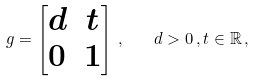<formula> <loc_0><loc_0><loc_500><loc_500>g = \begin{bmatrix} d & t \\ 0 & 1 \end{bmatrix} \, , \quad d > 0 \, , t \in \mathbb { R } \, ,</formula> 